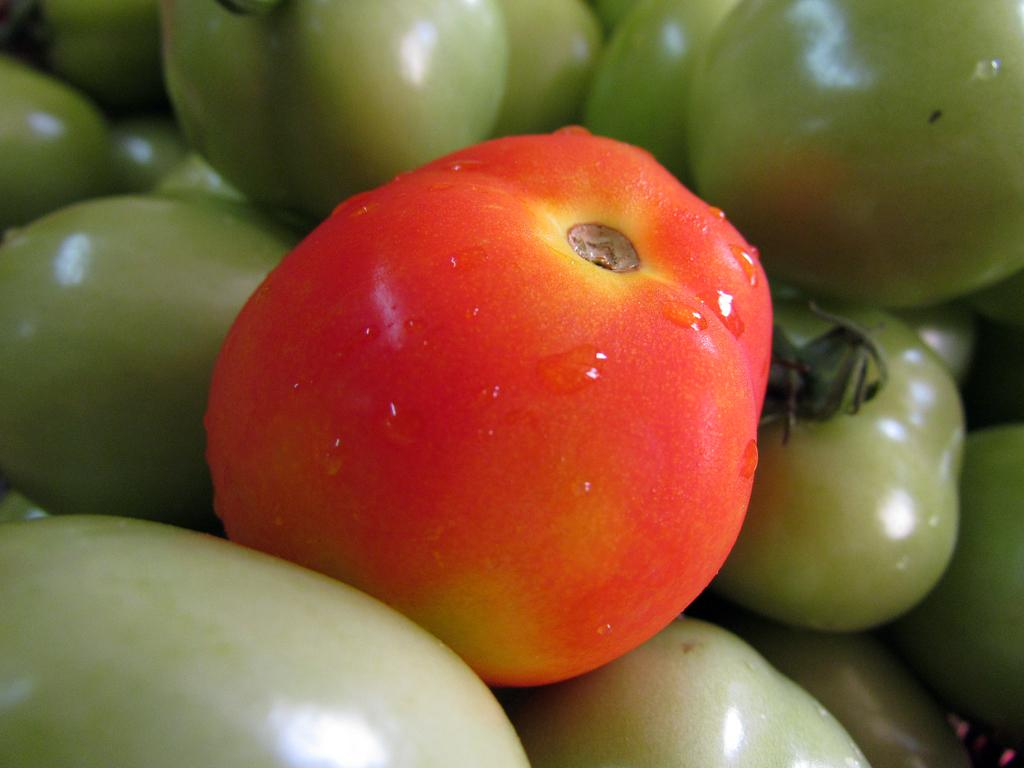What type of tomatoes are present in the image? There are green tomatoes and a red tomato in the image. Can you describe the appearance of the red tomato? The red tomato has water droplets on it. What type of amusement can be seen in the image? There is no amusement present in the image; it features tomatoes. Is there a parent in the image? There is no parent present in the image; it features tomatoes. 